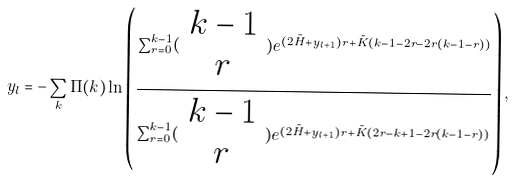Convert formula to latex. <formula><loc_0><loc_0><loc_500><loc_500>y _ { l } = - \sum _ { k } \Pi ( k ) \ln \left ( \frac { \sum _ { r = 0 } ^ { k - 1 } ( \begin{array} { c } k - 1 \\ r \\ \end{array} ) e ^ { ( 2 \tilde { H } + y _ { l + 1 } ) r + \tilde { K } ( k - 1 - 2 r - 2 r ( k - 1 - r ) ) } } { \sum _ { r = 0 } ^ { k - 1 } ( \begin{array} { c } k - 1 \\ r \\ \end{array} ) e ^ { ( 2 \tilde { H } + y _ { l + 1 } ) r + \tilde { K } ( 2 r - k + 1 - 2 r ( k - 1 - r ) ) } } \right ) ,</formula> 